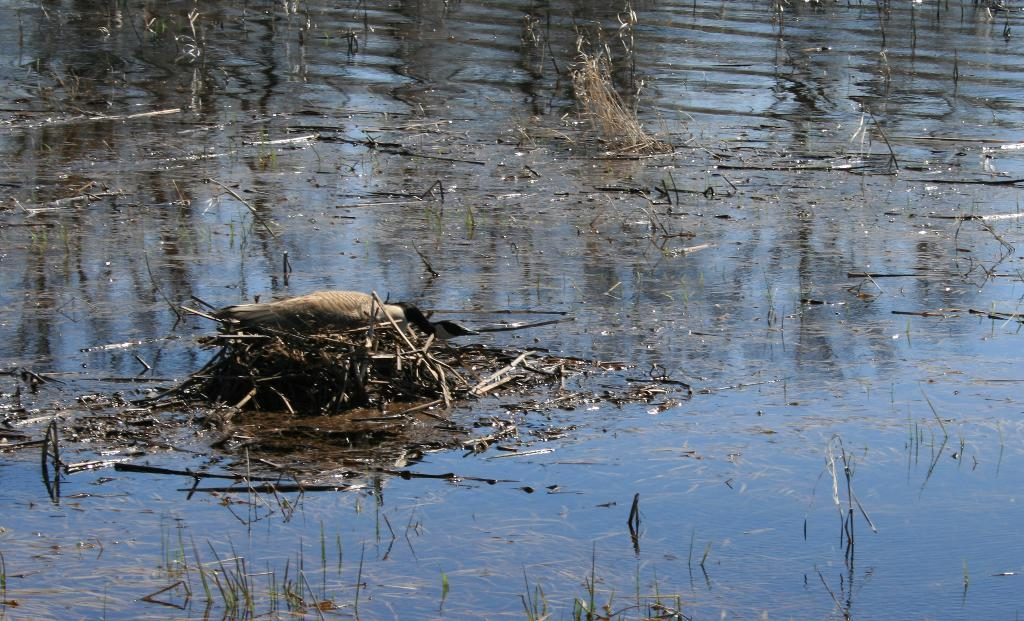What type of animal can be seen in the picture? There is a bird in the picture. What is the primary element in which the bird is situated? There is water visible in the picture, and it might be in a pond. What type of vegetation is present in the picture? There is grass in the picture. What other objects can be seen in the picture? There are twigs in the picture. Can you tell me how many potatoes are visible in the picture? There are no potatoes present in the image; it features a bird, water, grass, and twigs. 